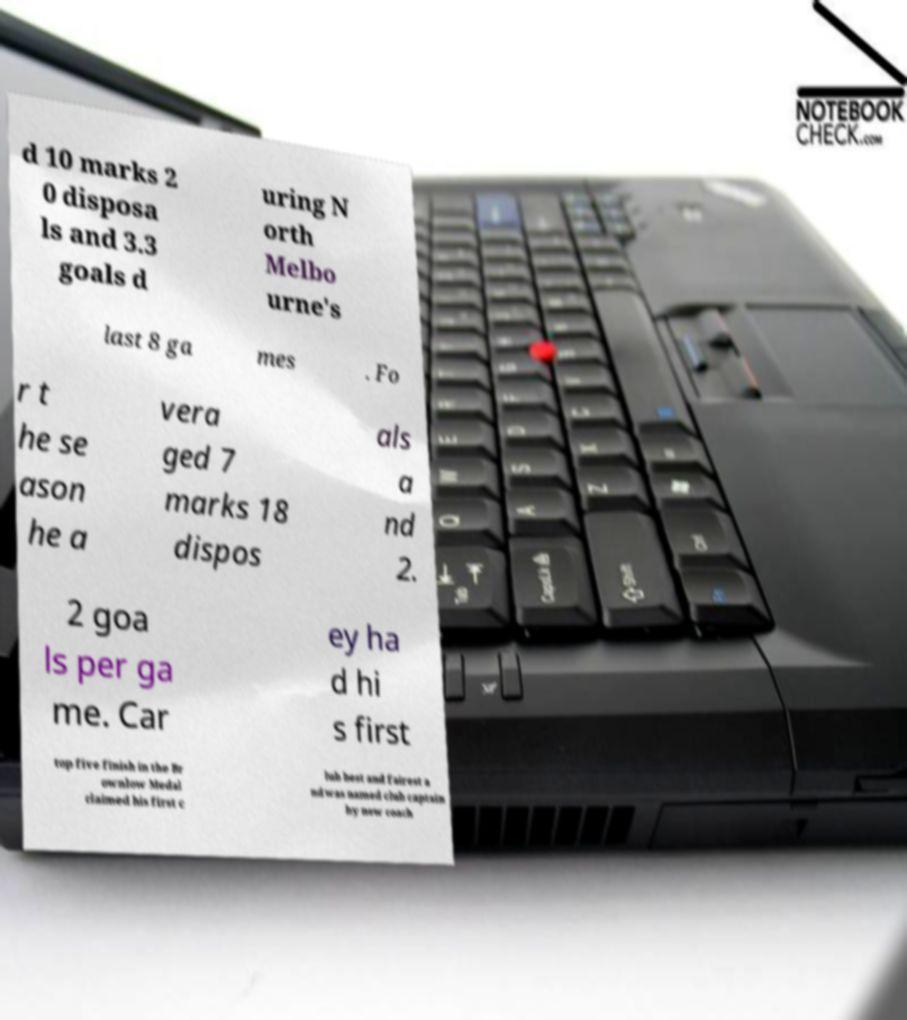Please identify and transcribe the text found in this image. d 10 marks 2 0 disposa ls and 3.3 goals d uring N orth Melbo urne's last 8 ga mes . Fo r t he se ason he a vera ged 7 marks 18 dispos als a nd 2. 2 goa ls per ga me. Car ey ha d hi s first top five finish in the Br ownlow Medal claimed his first c lub best and fairest a nd was named club captain by new coach 